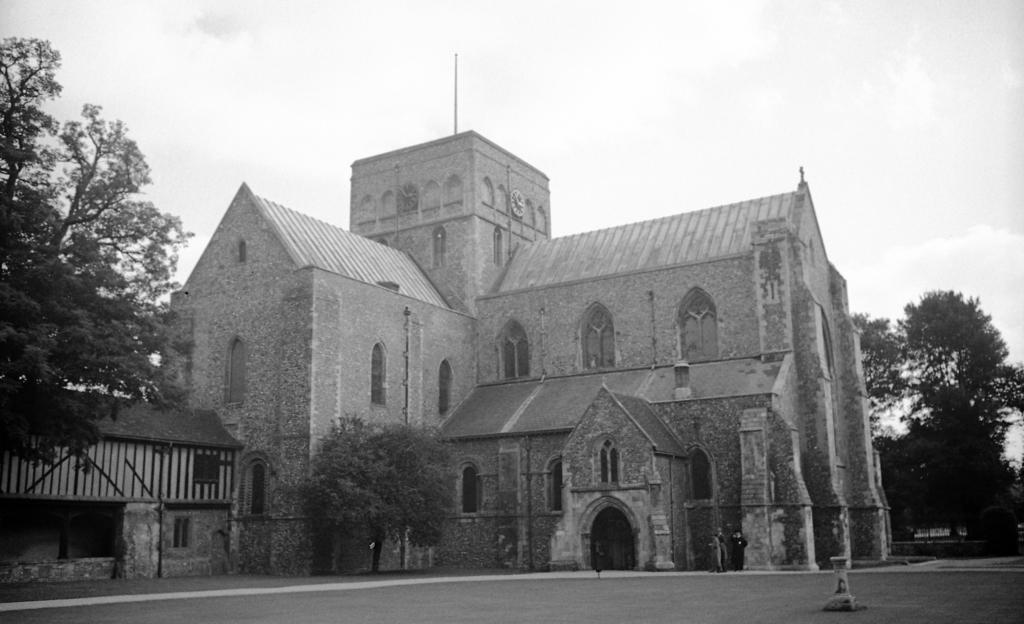Describe this image in one or two sentences. This is a black and white image. At the bottom of this image there is a road. Here I can see a building and trees. On the top of the image I can see the sky. 